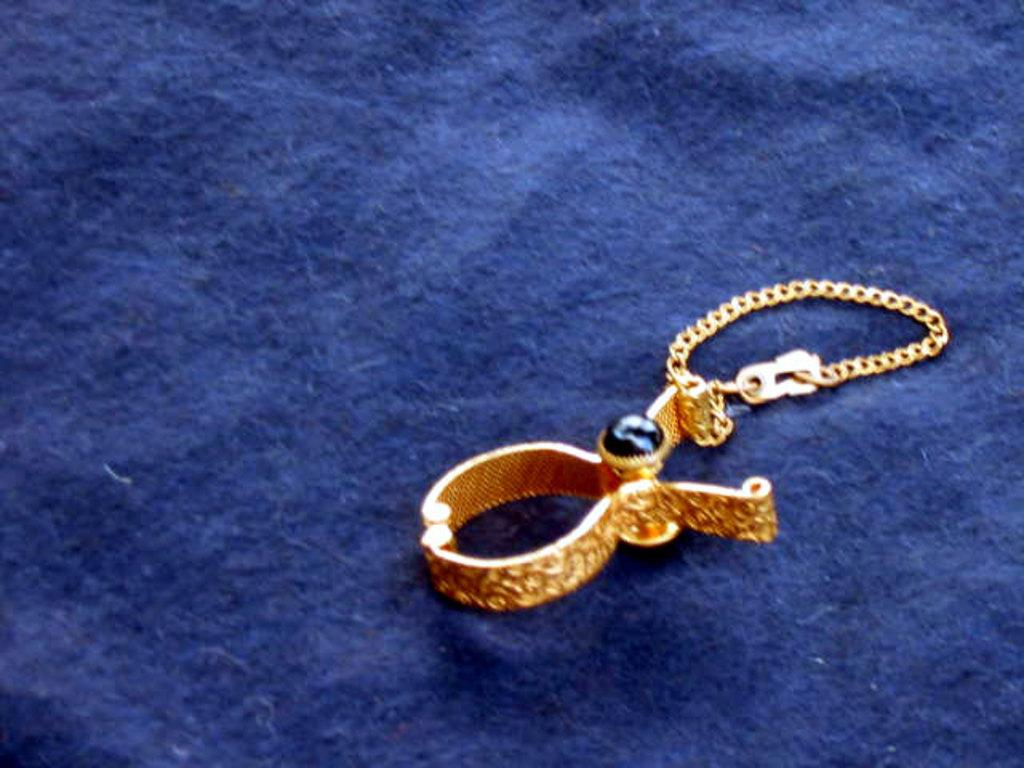What is the main object in the image? There is an ornament in the image. Where is the ornament located? The ornament is on a platform. What type of work is the ornament doing in the image? The ornament is not performing any work in the image; it is simply an object on display. 